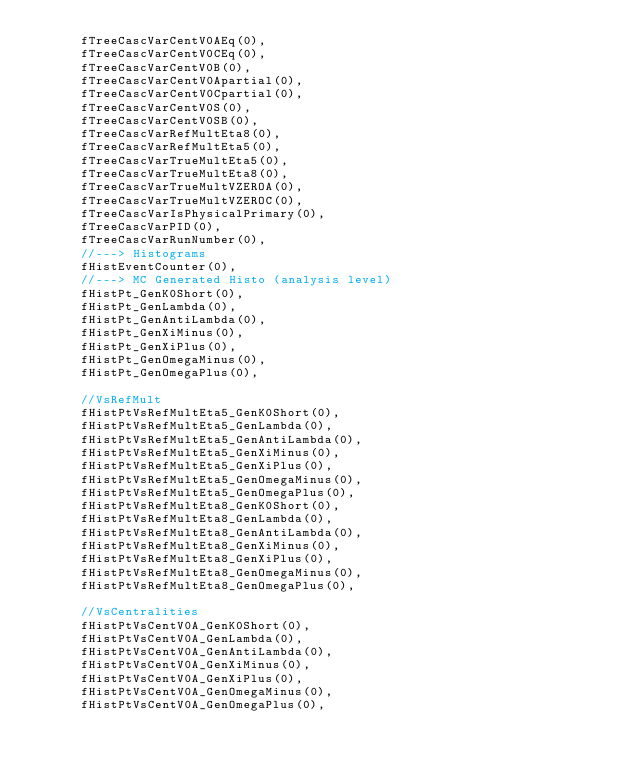<code> <loc_0><loc_0><loc_500><loc_500><_C++_>      fTreeCascVarCentV0AEq(0),
      fTreeCascVarCentV0CEq(0),
      fTreeCascVarCentV0B(0),
      fTreeCascVarCentV0Apartial(0),
      fTreeCascVarCentV0Cpartial(0),
      fTreeCascVarCentV0S(0),
      fTreeCascVarCentV0SB(0),
      fTreeCascVarRefMultEta8(0),
      fTreeCascVarRefMultEta5(0),
      fTreeCascVarTrueMultEta5(0),
      fTreeCascVarTrueMultEta8(0),
      fTreeCascVarTrueMultVZEROA(0),
      fTreeCascVarTrueMultVZEROC(0),
      fTreeCascVarIsPhysicalPrimary(0),
      fTreeCascVarPID(0),
      fTreeCascVarRunNumber(0),
      //---> Histograms
      fHistEventCounter(0),
      //---> MC Generated Histo (analysis level)
      fHistPt_GenK0Short(0),
      fHistPt_GenLambda(0),
      fHistPt_GenAntiLambda(0),
      fHistPt_GenXiMinus(0),
      fHistPt_GenXiPlus(0),
      fHistPt_GenOmegaMinus(0),
      fHistPt_GenOmegaPlus(0),

      //VsRefMult
      fHistPtVsRefMultEta5_GenK0Short(0),
      fHistPtVsRefMultEta5_GenLambda(0),
      fHistPtVsRefMultEta5_GenAntiLambda(0),
      fHistPtVsRefMultEta5_GenXiMinus(0),
      fHistPtVsRefMultEta5_GenXiPlus(0),
      fHistPtVsRefMultEta5_GenOmegaMinus(0),
      fHistPtVsRefMultEta5_GenOmegaPlus(0),
      fHistPtVsRefMultEta8_GenK0Short(0),
      fHistPtVsRefMultEta8_GenLambda(0),
      fHistPtVsRefMultEta8_GenAntiLambda(0),
      fHistPtVsRefMultEta8_GenXiMinus(0),
      fHistPtVsRefMultEta8_GenXiPlus(0),
      fHistPtVsRefMultEta8_GenOmegaMinus(0),
      fHistPtVsRefMultEta8_GenOmegaPlus(0),

      //VsCentralities
      fHistPtVsCentV0A_GenK0Short(0),
      fHistPtVsCentV0A_GenLambda(0),
      fHistPtVsCentV0A_GenAntiLambda(0),
      fHistPtVsCentV0A_GenXiMinus(0),
      fHistPtVsCentV0A_GenXiPlus(0),
      fHistPtVsCentV0A_GenOmegaMinus(0),
      fHistPtVsCentV0A_GenOmegaPlus(0),</code> 